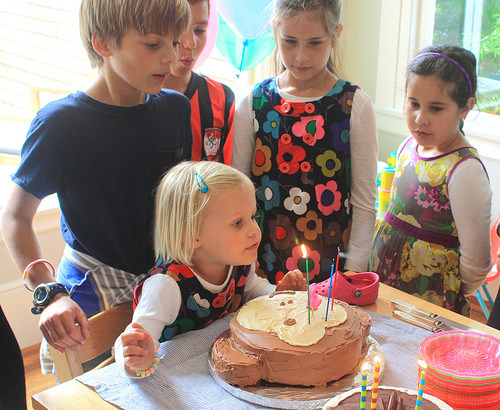<image>
Is there a shoe on the girl? No. The shoe is not positioned on the girl. They may be near each other, but the shoe is not supported by or resting on top of the girl. Where is the girl in relation to the girl? Is it behind the girl? No. The girl is not behind the girl. From this viewpoint, the girl appears to be positioned elsewhere in the scene. 